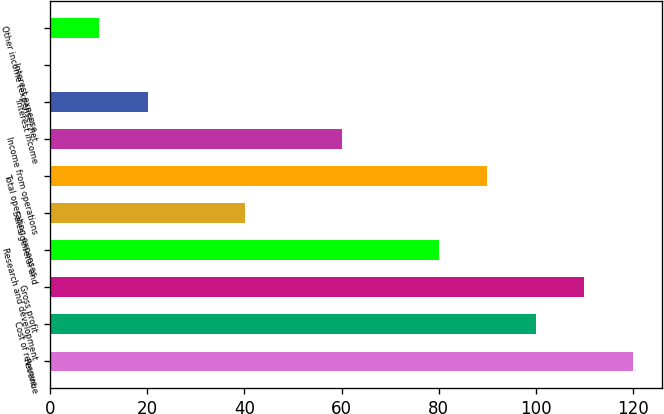<chart> <loc_0><loc_0><loc_500><loc_500><bar_chart><fcel>Revenue<fcel>Cost of revenue<fcel>Gross profit<fcel>Research and development<fcel>Sales general and<fcel>Total operating expenses<fcel>Income from operations<fcel>Interest income<fcel>Interest expense<fcel>Other income (expense) net<nl><fcel>119.98<fcel>100<fcel>109.99<fcel>80.02<fcel>40.06<fcel>90.01<fcel>60.04<fcel>20.08<fcel>0.1<fcel>10.09<nl></chart> 